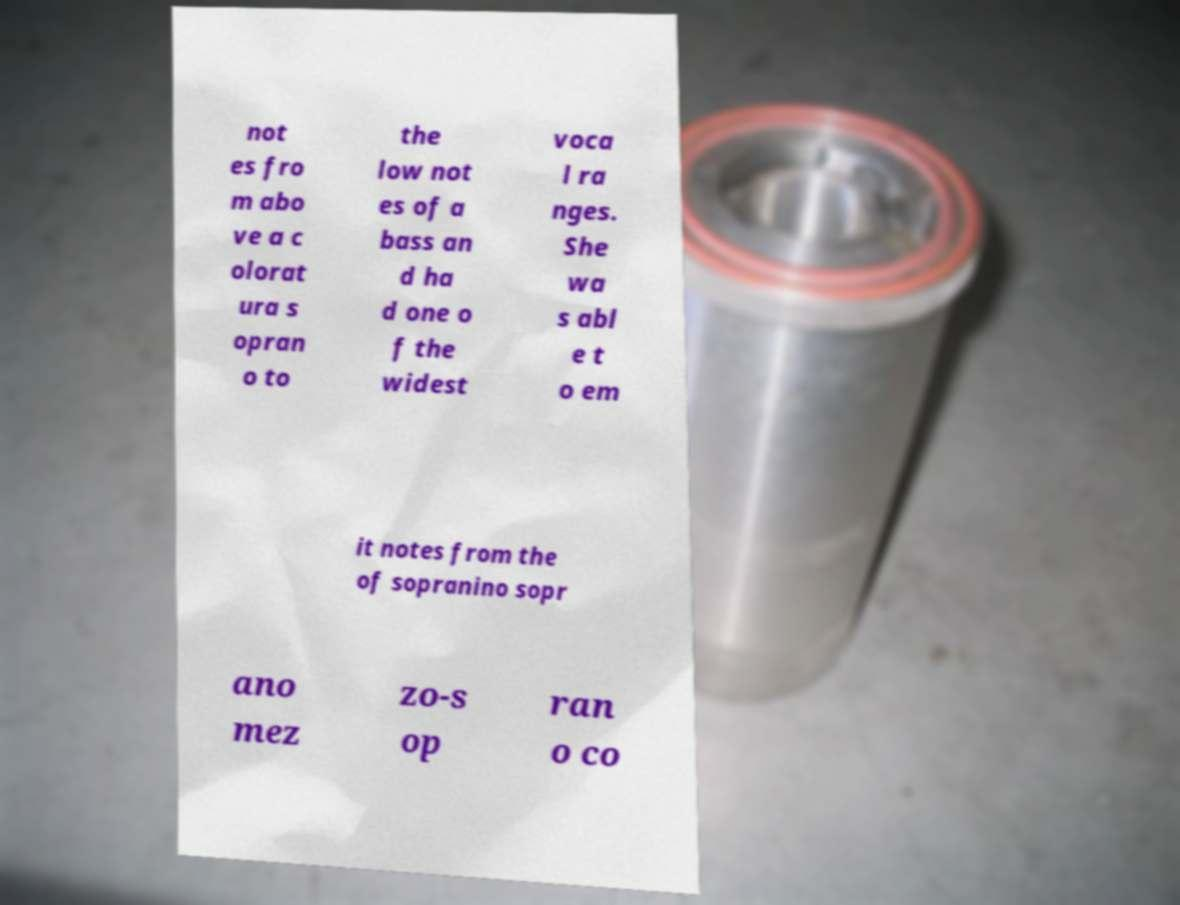Please read and relay the text visible in this image. What does it say? not es fro m abo ve a c olorat ura s opran o to the low not es of a bass an d ha d one o f the widest voca l ra nges. She wa s abl e t o em it notes from the of sopranino sopr ano mez zo-s op ran o co 